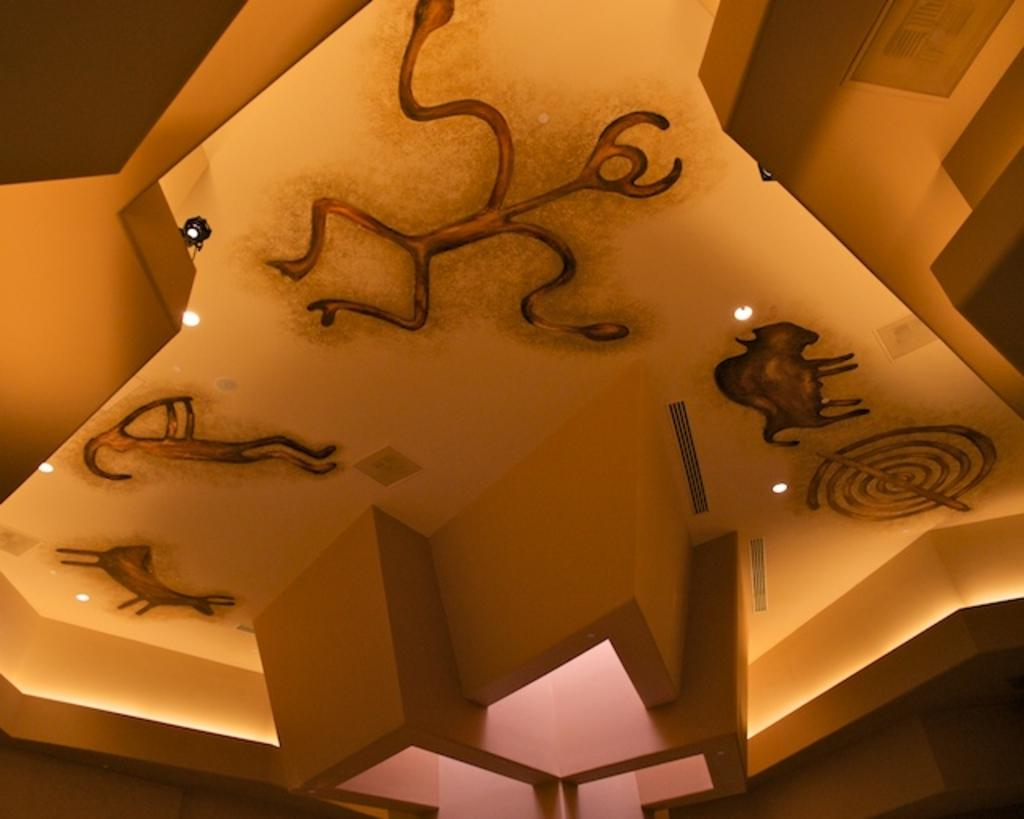What type of ceiling is featured in the image? There is a designer ceiling in the image. What can be seen in the image that provides illumination? There are lights in the image. What other architectural feature is visible in the image? Air ducts are visible in the image. How many girls are playing with the tiger in the image? There are no girls or tigers present in the image. 